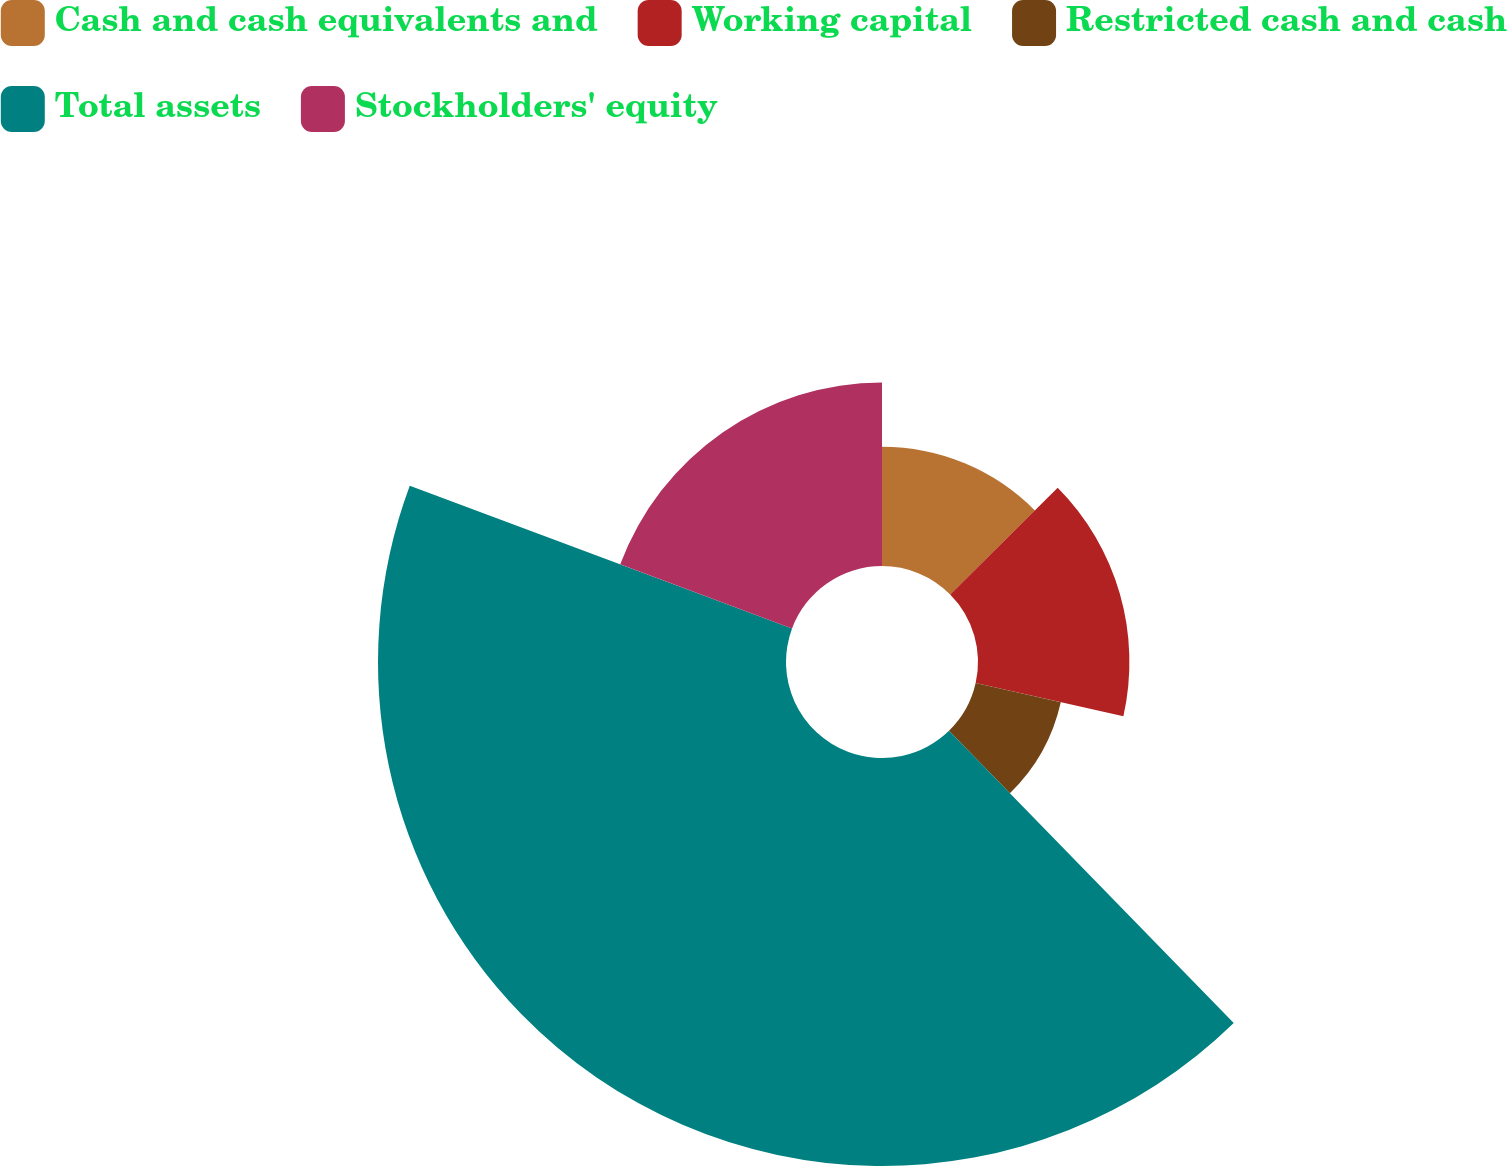<chart> <loc_0><loc_0><loc_500><loc_500><pie_chart><fcel>Cash and cash equivalents and<fcel>Working capital<fcel>Restricted cash and cash<fcel>Total assets<fcel>Stockholders' equity<nl><fcel>12.57%<fcel>15.95%<fcel>9.19%<fcel>42.98%<fcel>19.32%<nl></chart> 